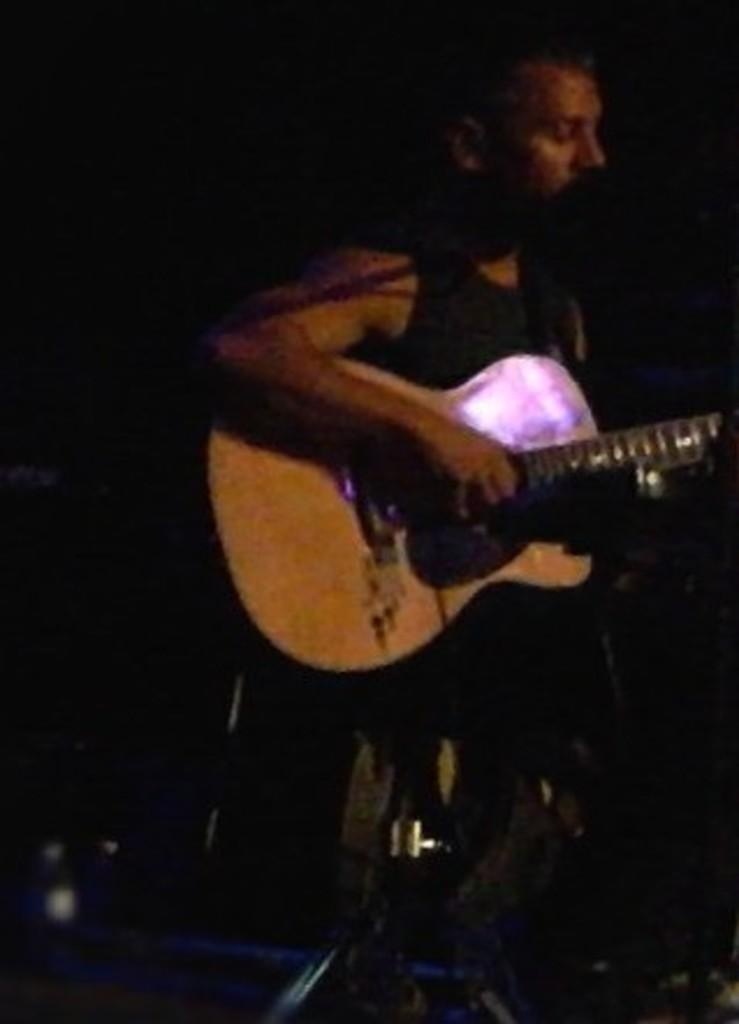What is the main subject of the image? There is a person in the image. What is the person holding in the image? The person is holding a guitar. What is the person doing with the guitar? The person is playing the guitar. Can you hear the person whistling in the image? There is no sound in the image, so it cannot be determined if the person is whistling or not. 